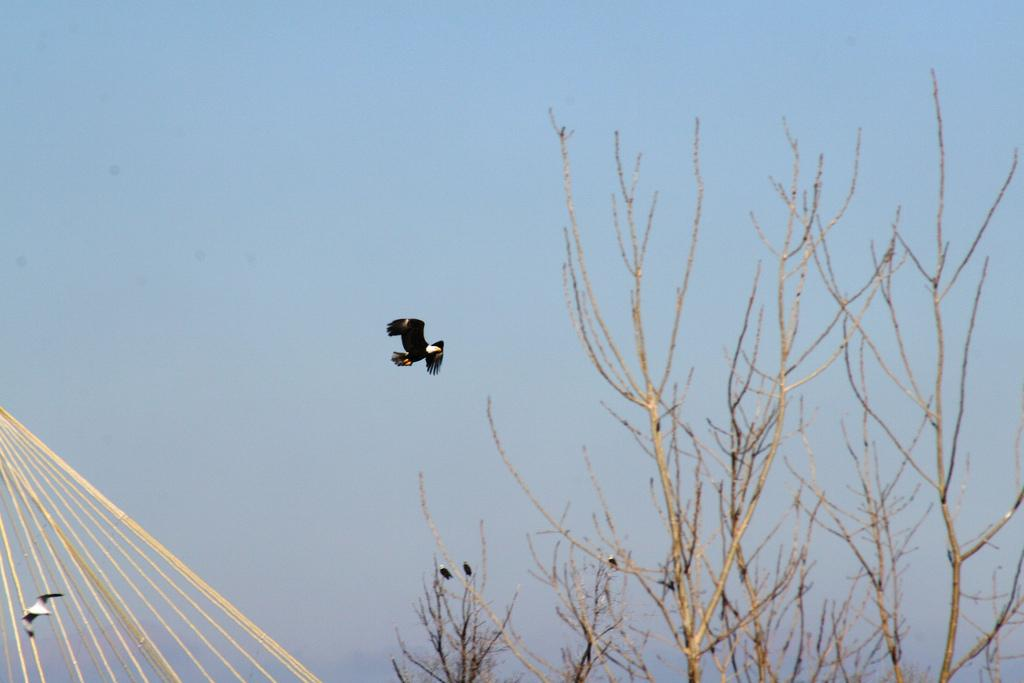What is flying in the sky in the image? There is a bird in the sky in the image. What type of vegetation can be seen in the image? There are trees visible in the image. What is located on the left side of the image? There are tapes on the left side of the image. What is visible in the background of the image? The sky is visible in the background of the image. How many cars are parked under the trees in the image? There are no cars present in the image; it features a bird in the sky, trees, tapes, and a visible sky in the background. What time does the clock show in the image? There is no clock present in the image. 